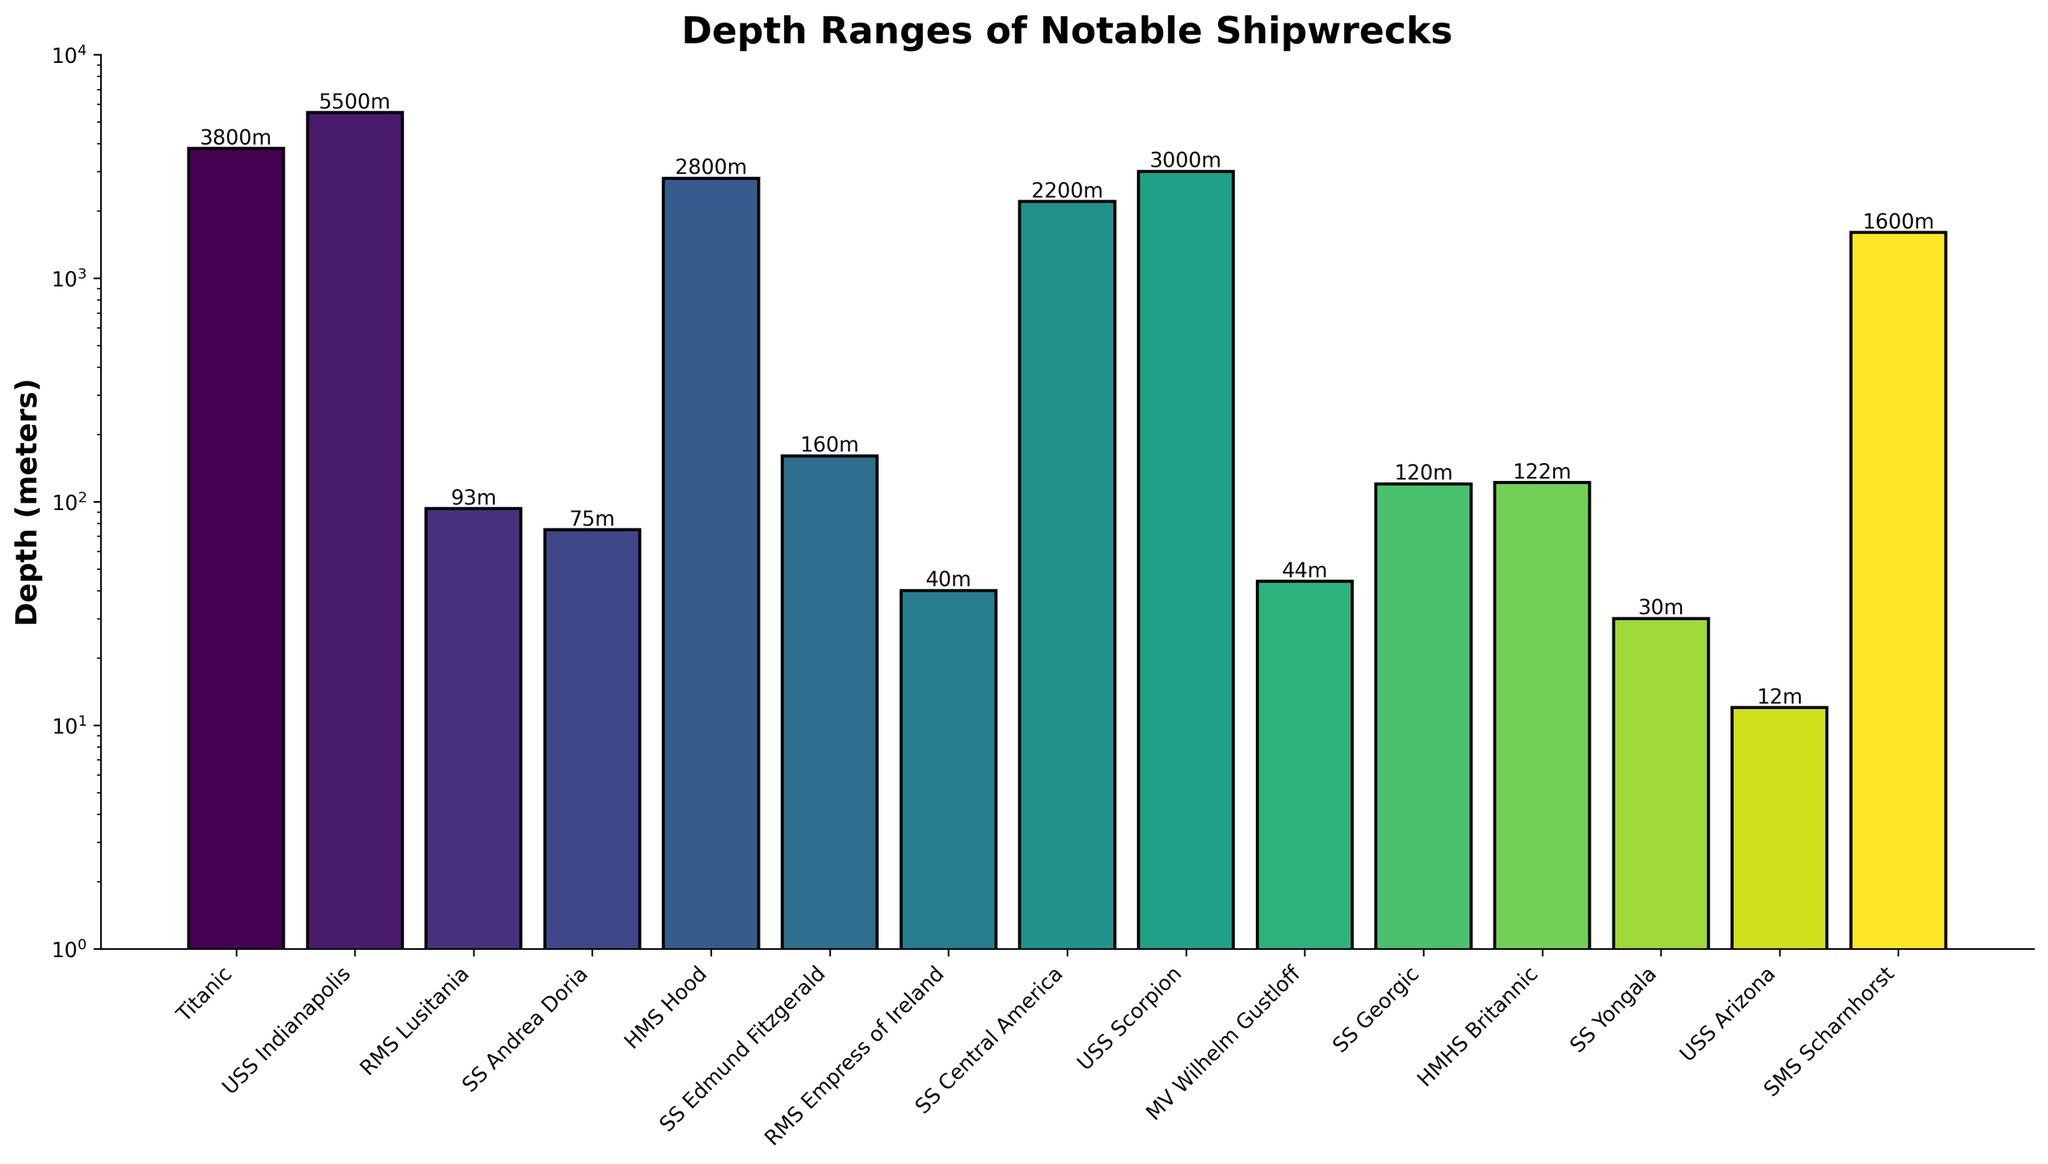What is the deepest shipwreck according to the figure? By looking at the tallest bar in the figure, we can see which shipwreck corresponds to the highest value on the vertical axis labeled in meters.
Answer: USS Indianapolis Which shipwreck is at a shallower depth: SS Andrea Doria or RMS Lusitania? Compare the height of the bars corresponding to SS Andrea Doria and RMS Lusitania. The bar for SS Andrea Doria is shorter than the one for RMS Lusitania, indicating a shallower depth.
Answer: SS Andrea Doria What is the average depth of the HMS Hood and SS Central America shipwrecks? To find the average depth, sum the depths of HMS Hood (2800 meters) and SS Central America (2200 meters), then divide by 2. (2800+2200)/2 = 2500 meters.
Answer: 2500 meters Which shipwrecks are found at depths shallower than 100 meters? Identify the bars with heights corresponding to depths less than 100 meters. These shipwrecks are RMS Lusitania (93 meters), SS Andrea Doria (75 meters), RMS Empress of Ireland (40 meters), MV Wilhelm Gustloff (44 meters), SS Yongala (30 meters), and USS Arizona (12 meters).
Answer: RMS Lusitania, SS Andrea Doria, RMS Empress of Ireland, MV Wilhelm Gustloff, SS Yongala, USS Arizona Compare the depths of Titanic and HMS Hood. Which one is deeper and by how much? Titanic has a depth of 3800 meters and HMS Hood is at 2800 meters. Subtract the depth of HMS Hood from that of Titanic (3800 - 2800).
Answer: Titanic is deeper by 1000 meters Which shipwreck's depth falls within the color gradient towards green? Look at the bars that are visually more towards the green spectrum. The bars for HMS Hood and SS Central America fall within this gradient.
Answer: HMS Hood, SS Central America Are there more shipwrecks found at depths greater than 1000 meters or less than 1000 meters? Count the number of bars exceeding 1000 meters in height and those below 1000 meters. Greater than 1000 meters: Titanic, USS Indianapolis, HMS Hood, SS Central America, USS Scorpion, SMS Scharnhorst. Less than 1000 meters: RMS Lusitania, SS Andrea Doria, SS Edmund Fitzgerald, RMS Empress of Ireland, MV Wilhelm Gustloff, SS Georgic, HMHS Britannic, SS Yongala, USS Arizona.
Answer: Less than 1000 meters What is the log-scale interval for the depths represented on the y-axis? Observe the tick marks on the y-axis to determine the intervals, which typically progress by a factor of 10 in a log scale.
Answer: Multiples of 10 Which shipwreck is closest to Titanic in terms of depth? Identify the shipwreck with a depth closest to 3800 meters, which is the depth of Titanic. The closest is HMS Hood at 2800 meters.
Answer: HMS Hood 